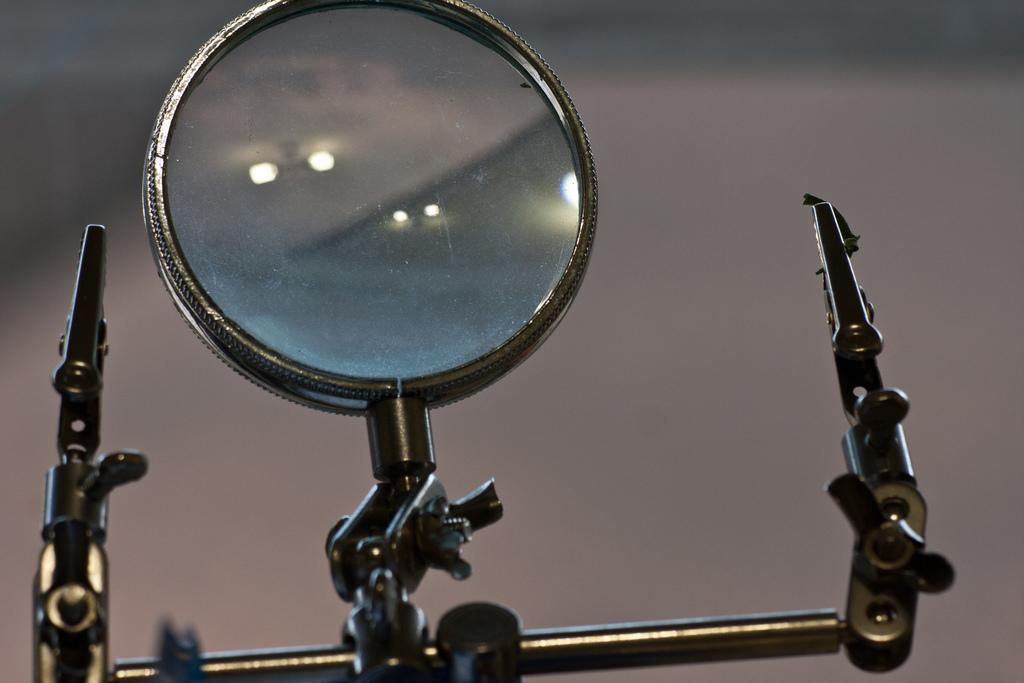What object is present in the image that can be used for reflection? There is a mirror in the image. How is the mirror positioned in the image? The mirror is on a stand. What can be observed about the background of the image? The background of the image is blurry. What can be seen in the mirror in the image? There are lights reflected in the mirror. What type of leather is being sold at the market in the image? There is no market or leather present in the image; it features a mirror on a stand with lights reflected in it. 